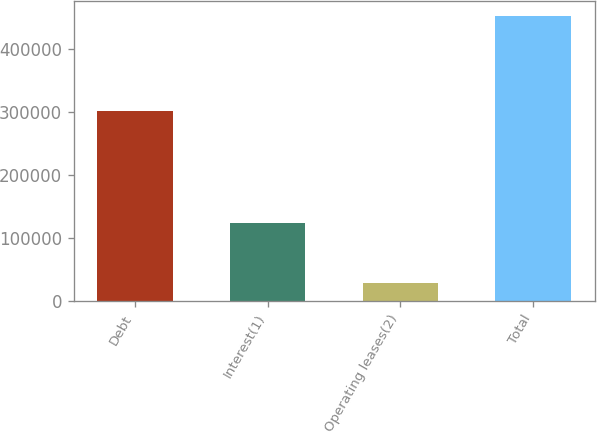Convert chart to OTSL. <chart><loc_0><loc_0><loc_500><loc_500><bar_chart><fcel>Debt<fcel>Interest(1)<fcel>Operating leases(2)<fcel>Total<nl><fcel>300906<fcel>123091<fcel>28173<fcel>452170<nl></chart> 